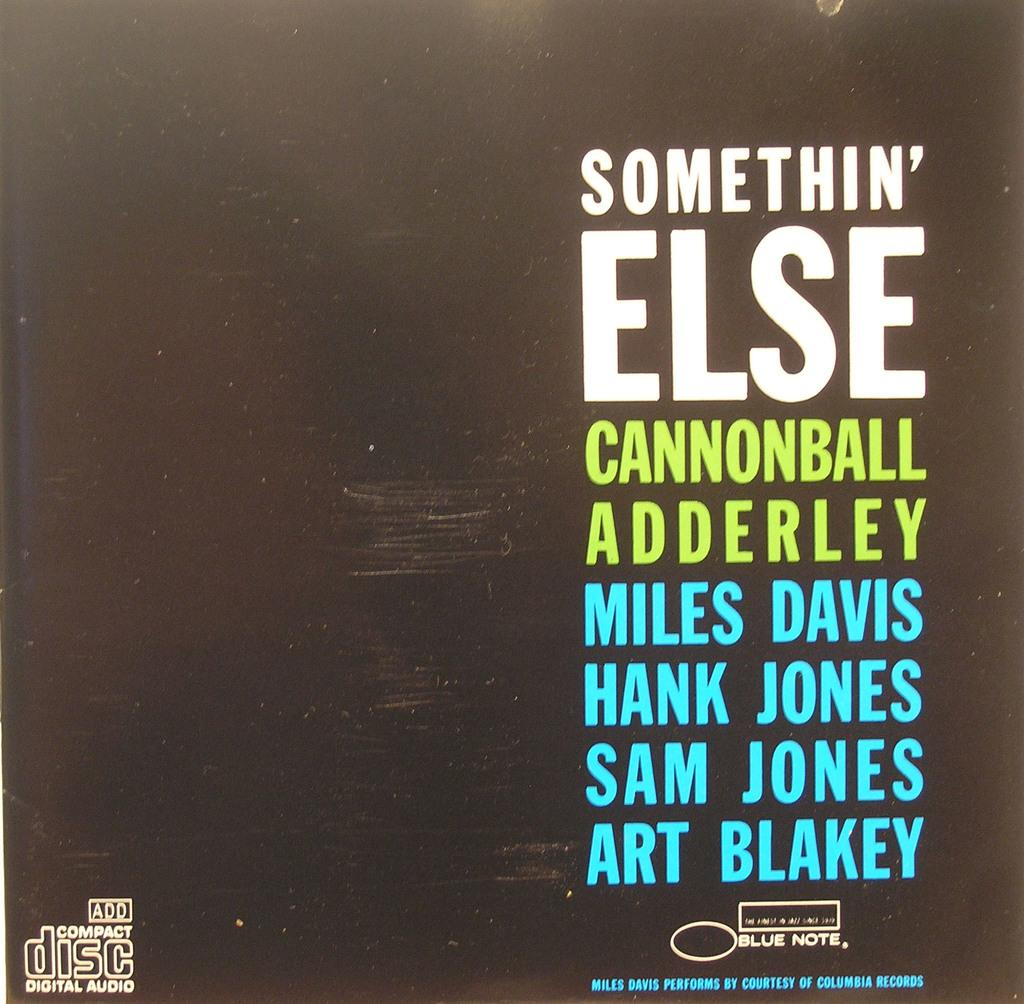<image>
Write a terse but informative summary of the picture. The CD cover for Somethin' Else by Cannonball Adderley, featuring Miles Davis, Hank Jones, Sam Jones and Art Blakey. 